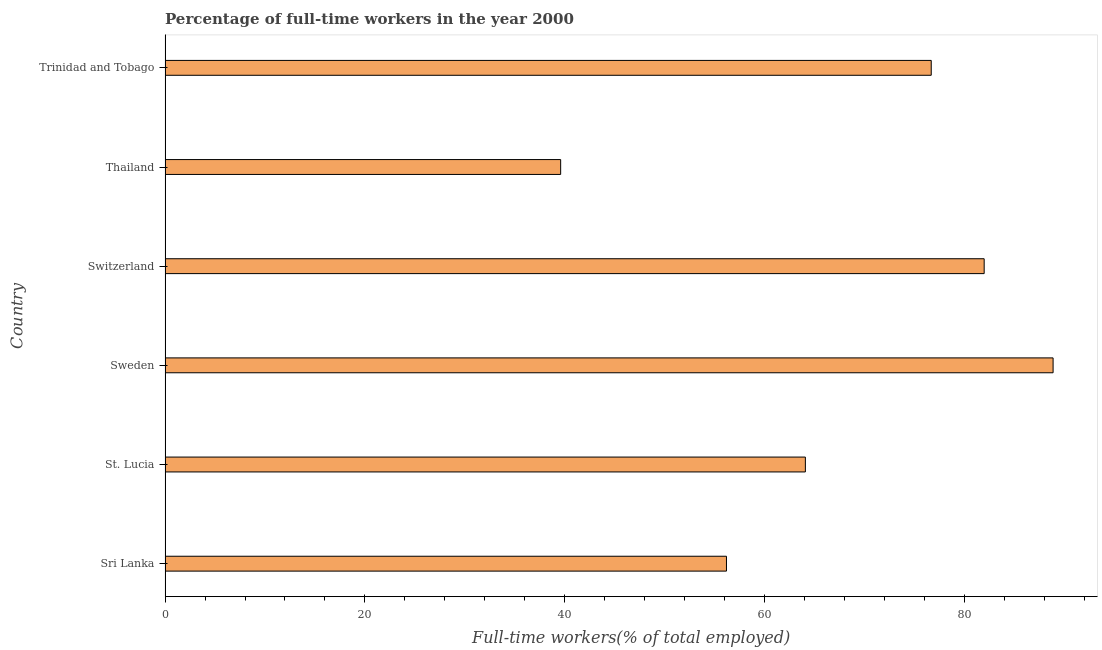Does the graph contain any zero values?
Make the answer very short. No. Does the graph contain grids?
Make the answer very short. No. What is the title of the graph?
Provide a short and direct response. Percentage of full-time workers in the year 2000. What is the label or title of the X-axis?
Your response must be concise. Full-time workers(% of total employed). What is the percentage of full-time workers in Switzerland?
Provide a short and direct response. 82. Across all countries, what is the maximum percentage of full-time workers?
Ensure brevity in your answer.  88.9. Across all countries, what is the minimum percentage of full-time workers?
Provide a succinct answer. 39.6. In which country was the percentage of full-time workers maximum?
Offer a very short reply. Sweden. In which country was the percentage of full-time workers minimum?
Provide a succinct answer. Thailand. What is the sum of the percentage of full-time workers?
Provide a succinct answer. 407.5. What is the difference between the percentage of full-time workers in Thailand and Trinidad and Tobago?
Ensure brevity in your answer.  -37.1. What is the average percentage of full-time workers per country?
Offer a very short reply. 67.92. What is the median percentage of full-time workers?
Your answer should be compact. 70.4. In how many countries, is the percentage of full-time workers greater than 84 %?
Your answer should be compact. 1. What is the ratio of the percentage of full-time workers in Sweden to that in Switzerland?
Ensure brevity in your answer.  1.08. Is the difference between the percentage of full-time workers in St. Lucia and Switzerland greater than the difference between any two countries?
Your answer should be compact. No. What is the difference between the highest and the lowest percentage of full-time workers?
Your answer should be compact. 49.3. In how many countries, is the percentage of full-time workers greater than the average percentage of full-time workers taken over all countries?
Offer a very short reply. 3. Are all the bars in the graph horizontal?
Provide a succinct answer. Yes. How many countries are there in the graph?
Keep it short and to the point. 6. What is the difference between two consecutive major ticks on the X-axis?
Give a very brief answer. 20. Are the values on the major ticks of X-axis written in scientific E-notation?
Offer a very short reply. No. What is the Full-time workers(% of total employed) of Sri Lanka?
Offer a very short reply. 56.2. What is the Full-time workers(% of total employed) of St. Lucia?
Offer a very short reply. 64.1. What is the Full-time workers(% of total employed) of Sweden?
Provide a short and direct response. 88.9. What is the Full-time workers(% of total employed) in Switzerland?
Your response must be concise. 82. What is the Full-time workers(% of total employed) in Thailand?
Your response must be concise. 39.6. What is the Full-time workers(% of total employed) in Trinidad and Tobago?
Provide a succinct answer. 76.7. What is the difference between the Full-time workers(% of total employed) in Sri Lanka and Sweden?
Provide a short and direct response. -32.7. What is the difference between the Full-time workers(% of total employed) in Sri Lanka and Switzerland?
Provide a succinct answer. -25.8. What is the difference between the Full-time workers(% of total employed) in Sri Lanka and Trinidad and Tobago?
Keep it short and to the point. -20.5. What is the difference between the Full-time workers(% of total employed) in St. Lucia and Sweden?
Give a very brief answer. -24.8. What is the difference between the Full-time workers(% of total employed) in St. Lucia and Switzerland?
Make the answer very short. -17.9. What is the difference between the Full-time workers(% of total employed) in St. Lucia and Trinidad and Tobago?
Your answer should be compact. -12.6. What is the difference between the Full-time workers(% of total employed) in Sweden and Thailand?
Keep it short and to the point. 49.3. What is the difference between the Full-time workers(% of total employed) in Switzerland and Thailand?
Ensure brevity in your answer.  42.4. What is the difference between the Full-time workers(% of total employed) in Thailand and Trinidad and Tobago?
Provide a short and direct response. -37.1. What is the ratio of the Full-time workers(% of total employed) in Sri Lanka to that in St. Lucia?
Your answer should be very brief. 0.88. What is the ratio of the Full-time workers(% of total employed) in Sri Lanka to that in Sweden?
Ensure brevity in your answer.  0.63. What is the ratio of the Full-time workers(% of total employed) in Sri Lanka to that in Switzerland?
Keep it short and to the point. 0.69. What is the ratio of the Full-time workers(% of total employed) in Sri Lanka to that in Thailand?
Provide a short and direct response. 1.42. What is the ratio of the Full-time workers(% of total employed) in Sri Lanka to that in Trinidad and Tobago?
Your answer should be compact. 0.73. What is the ratio of the Full-time workers(% of total employed) in St. Lucia to that in Sweden?
Offer a very short reply. 0.72. What is the ratio of the Full-time workers(% of total employed) in St. Lucia to that in Switzerland?
Give a very brief answer. 0.78. What is the ratio of the Full-time workers(% of total employed) in St. Lucia to that in Thailand?
Offer a very short reply. 1.62. What is the ratio of the Full-time workers(% of total employed) in St. Lucia to that in Trinidad and Tobago?
Your response must be concise. 0.84. What is the ratio of the Full-time workers(% of total employed) in Sweden to that in Switzerland?
Ensure brevity in your answer.  1.08. What is the ratio of the Full-time workers(% of total employed) in Sweden to that in Thailand?
Provide a succinct answer. 2.25. What is the ratio of the Full-time workers(% of total employed) in Sweden to that in Trinidad and Tobago?
Your answer should be compact. 1.16. What is the ratio of the Full-time workers(% of total employed) in Switzerland to that in Thailand?
Ensure brevity in your answer.  2.07. What is the ratio of the Full-time workers(% of total employed) in Switzerland to that in Trinidad and Tobago?
Give a very brief answer. 1.07. What is the ratio of the Full-time workers(% of total employed) in Thailand to that in Trinidad and Tobago?
Give a very brief answer. 0.52. 